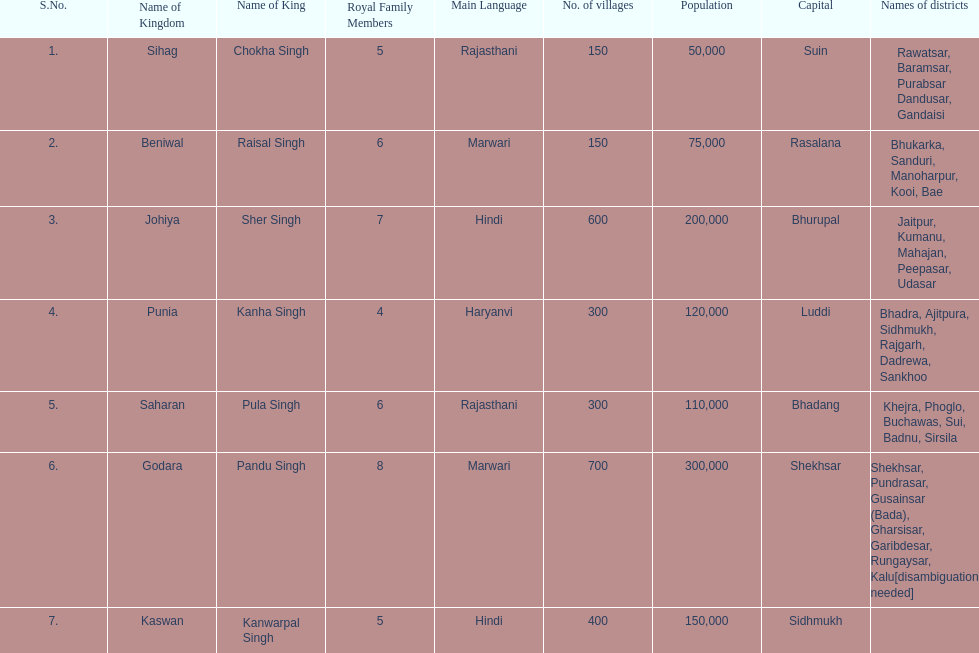What was the total number of districts within the state of godara? 7. 